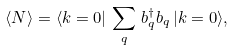Convert formula to latex. <formula><loc_0><loc_0><loc_500><loc_500>\langle N \rangle = \langle { k } = 0 | \, \sum _ { q } \, b ^ { \dag } _ { q } b _ { q } \, | { k } = 0 \rangle ,</formula> 